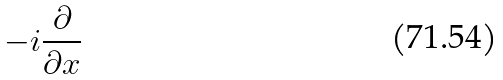<formula> <loc_0><loc_0><loc_500><loc_500>- i \frac { \partial } { \partial x }</formula> 